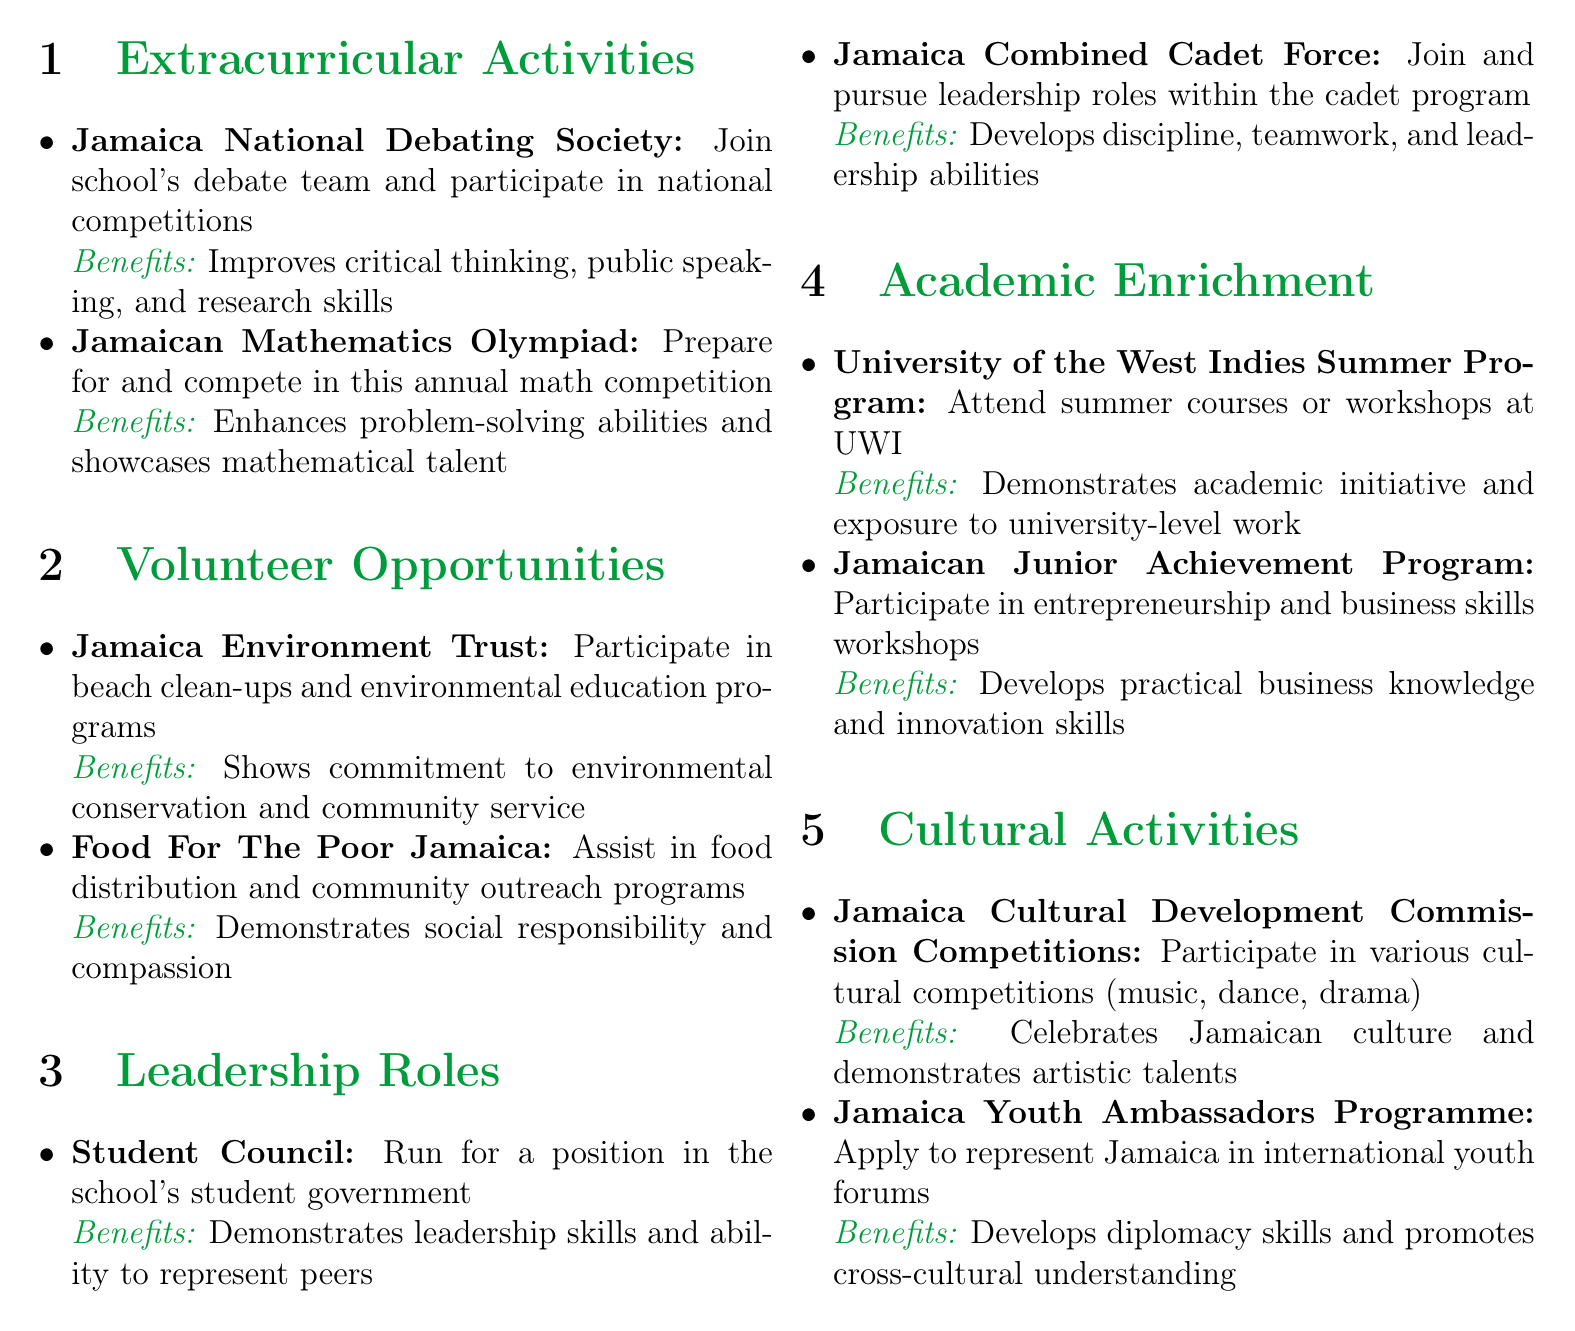What is the name of a debating society in Jamaica? The document lists "Jamaica National Debating Society" as one of the extracurricular activities.
Answer: Jamaica National Debating Society What type of program is offered by the Jamaica Library Service? The document mentions volunteering in reading programs or book drives at local libraries.
Answer: Reading programs or book drives Which leadership role involves founding a school club? The document specifies "School Club Founder" as a potential leadership role.
Answer: School Club Founder Name one of the volunteer opportunities focused on environmental conservation. The document highlights "Jamaica Environment Trust" as a volunteer opportunity related to environmental conservation.
Answer: Jamaica Environment Trust What does participating in the Jamaican Mathematics Olympiad enhance? The document states it enhances problem-solving abilities.
Answer: Problem-solving abilities What is the primary benefit of the University of the West Indies Summer Program? The document indicates the primary benefit is demonstrating academic initiative.
Answer: Demonstrates academic initiative How many cultural activities are listed in the document? The document lists three cultural activities under the "Cultural Activities" section.
Answer: Three Which extracurricular activity shows dedication to the arts? "National Youth Orchestra of Jamaica" is mentioned as showcasing musical talent and dedication to the arts.
Answer: National Youth Orchestra of Jamaica What role does the Student Council represent? The explanation mentions that it represents peers within the school's student government.
Answer: Peers 